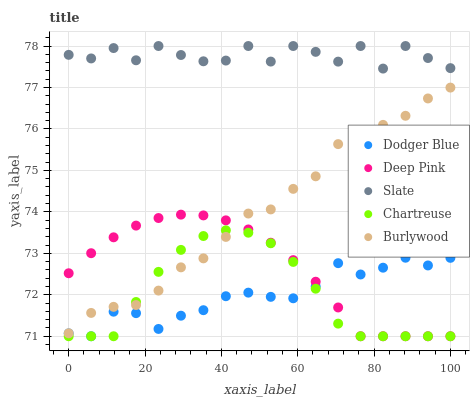Does Dodger Blue have the minimum area under the curve?
Answer yes or no. Yes. Does Slate have the maximum area under the curve?
Answer yes or no. Yes. Does Deep Pink have the minimum area under the curve?
Answer yes or no. No. Does Deep Pink have the maximum area under the curve?
Answer yes or no. No. Is Deep Pink the smoothest?
Answer yes or no. Yes. Is Slate the roughest?
Answer yes or no. Yes. Is Slate the smoothest?
Answer yes or no. No. Is Deep Pink the roughest?
Answer yes or no. No. Does Deep Pink have the lowest value?
Answer yes or no. Yes. Does Slate have the lowest value?
Answer yes or no. No. Does Slate have the highest value?
Answer yes or no. Yes. Does Deep Pink have the highest value?
Answer yes or no. No. Is Dodger Blue less than Slate?
Answer yes or no. Yes. Is Burlywood greater than Dodger Blue?
Answer yes or no. Yes. Does Chartreuse intersect Dodger Blue?
Answer yes or no. Yes. Is Chartreuse less than Dodger Blue?
Answer yes or no. No. Is Chartreuse greater than Dodger Blue?
Answer yes or no. No. Does Dodger Blue intersect Slate?
Answer yes or no. No. 